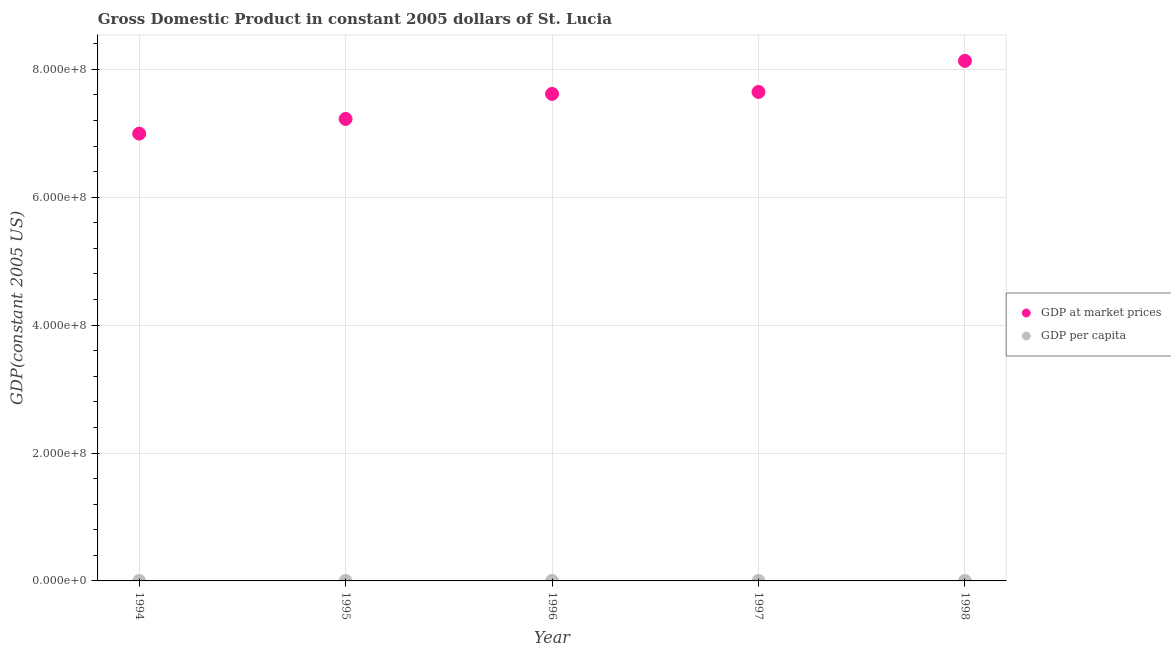What is the gdp per capita in 1997?
Offer a terse response. 5063.96. Across all years, what is the maximum gdp per capita?
Your answer should be very brief. 5312.77. Across all years, what is the minimum gdp at market prices?
Make the answer very short. 6.99e+08. In which year was the gdp per capita maximum?
Provide a succinct answer. 1998. In which year was the gdp per capita minimum?
Give a very brief answer. 1994. What is the total gdp per capita in the graph?
Keep it short and to the point. 2.52e+04. What is the difference between the gdp at market prices in 1995 and that in 1996?
Your answer should be very brief. -3.91e+07. What is the difference between the gdp per capita in 1996 and the gdp at market prices in 1995?
Your response must be concise. -7.22e+08. What is the average gdp at market prices per year?
Offer a very short reply. 7.52e+08. In the year 1997, what is the difference between the gdp at market prices and gdp per capita?
Your response must be concise. 7.65e+08. In how many years, is the gdp per capita greater than 80000000 US$?
Ensure brevity in your answer.  0. What is the ratio of the gdp per capita in 1995 to that in 1998?
Your answer should be very brief. 0.92. What is the difference between the highest and the second highest gdp per capita?
Your answer should be very brief. 200.38. What is the difference between the highest and the lowest gdp per capita?
Your answer should be very brief. 497.87. Does the gdp per capita monotonically increase over the years?
Provide a short and direct response. No. Is the gdp at market prices strictly greater than the gdp per capita over the years?
Provide a short and direct response. Yes. Is the gdp per capita strictly less than the gdp at market prices over the years?
Offer a terse response. Yes. How many years are there in the graph?
Your response must be concise. 5. Are the values on the major ticks of Y-axis written in scientific E-notation?
Ensure brevity in your answer.  Yes. Does the graph contain grids?
Your answer should be compact. Yes. Where does the legend appear in the graph?
Make the answer very short. Center right. How many legend labels are there?
Your answer should be compact. 2. What is the title of the graph?
Keep it short and to the point. Gross Domestic Product in constant 2005 dollars of St. Lucia. Does "Resident" appear as one of the legend labels in the graph?
Ensure brevity in your answer.  No. What is the label or title of the X-axis?
Offer a terse response. Year. What is the label or title of the Y-axis?
Your answer should be compact. GDP(constant 2005 US). What is the GDP(constant 2005 US) in GDP at market prices in 1994?
Ensure brevity in your answer.  6.99e+08. What is the GDP(constant 2005 US) of GDP per capita in 1994?
Provide a succinct answer. 4814.9. What is the GDP(constant 2005 US) in GDP at market prices in 1995?
Offer a very short reply. 7.22e+08. What is the GDP(constant 2005 US) in GDP per capita in 1995?
Offer a very short reply. 4913.07. What is the GDP(constant 2005 US) of GDP at market prices in 1996?
Your answer should be very brief. 7.62e+08. What is the GDP(constant 2005 US) in GDP per capita in 1996?
Provide a succinct answer. 5112.4. What is the GDP(constant 2005 US) in GDP at market prices in 1997?
Provide a succinct answer. 7.65e+08. What is the GDP(constant 2005 US) of GDP per capita in 1997?
Your response must be concise. 5063.96. What is the GDP(constant 2005 US) in GDP at market prices in 1998?
Offer a very short reply. 8.13e+08. What is the GDP(constant 2005 US) of GDP per capita in 1998?
Your answer should be compact. 5312.77. Across all years, what is the maximum GDP(constant 2005 US) in GDP at market prices?
Provide a short and direct response. 8.13e+08. Across all years, what is the maximum GDP(constant 2005 US) of GDP per capita?
Your answer should be very brief. 5312.77. Across all years, what is the minimum GDP(constant 2005 US) in GDP at market prices?
Your answer should be compact. 6.99e+08. Across all years, what is the minimum GDP(constant 2005 US) of GDP per capita?
Ensure brevity in your answer.  4814.9. What is the total GDP(constant 2005 US) in GDP at market prices in the graph?
Provide a succinct answer. 3.76e+09. What is the total GDP(constant 2005 US) of GDP per capita in the graph?
Ensure brevity in your answer.  2.52e+04. What is the difference between the GDP(constant 2005 US) in GDP at market prices in 1994 and that in 1995?
Your answer should be compact. -2.30e+07. What is the difference between the GDP(constant 2005 US) of GDP per capita in 1994 and that in 1995?
Ensure brevity in your answer.  -98.17. What is the difference between the GDP(constant 2005 US) of GDP at market prices in 1994 and that in 1996?
Your answer should be compact. -6.21e+07. What is the difference between the GDP(constant 2005 US) in GDP per capita in 1994 and that in 1996?
Your answer should be compact. -297.5. What is the difference between the GDP(constant 2005 US) of GDP at market prices in 1994 and that in 1997?
Offer a terse response. -6.52e+07. What is the difference between the GDP(constant 2005 US) of GDP per capita in 1994 and that in 1997?
Your response must be concise. -249.06. What is the difference between the GDP(constant 2005 US) in GDP at market prices in 1994 and that in 1998?
Offer a terse response. -1.14e+08. What is the difference between the GDP(constant 2005 US) in GDP per capita in 1994 and that in 1998?
Ensure brevity in your answer.  -497.87. What is the difference between the GDP(constant 2005 US) of GDP at market prices in 1995 and that in 1996?
Offer a very short reply. -3.91e+07. What is the difference between the GDP(constant 2005 US) in GDP per capita in 1995 and that in 1996?
Ensure brevity in your answer.  -199.33. What is the difference between the GDP(constant 2005 US) in GDP at market prices in 1995 and that in 1997?
Provide a short and direct response. -4.22e+07. What is the difference between the GDP(constant 2005 US) in GDP per capita in 1995 and that in 1997?
Provide a succinct answer. -150.89. What is the difference between the GDP(constant 2005 US) of GDP at market prices in 1995 and that in 1998?
Provide a short and direct response. -9.08e+07. What is the difference between the GDP(constant 2005 US) of GDP per capita in 1995 and that in 1998?
Provide a short and direct response. -399.7. What is the difference between the GDP(constant 2005 US) in GDP at market prices in 1996 and that in 1997?
Your answer should be compact. -3.07e+06. What is the difference between the GDP(constant 2005 US) in GDP per capita in 1996 and that in 1997?
Your answer should be compact. 48.44. What is the difference between the GDP(constant 2005 US) in GDP at market prices in 1996 and that in 1998?
Your response must be concise. -5.17e+07. What is the difference between the GDP(constant 2005 US) of GDP per capita in 1996 and that in 1998?
Your answer should be compact. -200.38. What is the difference between the GDP(constant 2005 US) of GDP at market prices in 1997 and that in 1998?
Your response must be concise. -4.86e+07. What is the difference between the GDP(constant 2005 US) of GDP per capita in 1997 and that in 1998?
Offer a very short reply. -248.82. What is the difference between the GDP(constant 2005 US) of GDP at market prices in 1994 and the GDP(constant 2005 US) of GDP per capita in 1995?
Make the answer very short. 6.99e+08. What is the difference between the GDP(constant 2005 US) of GDP at market prices in 1994 and the GDP(constant 2005 US) of GDP per capita in 1996?
Give a very brief answer. 6.99e+08. What is the difference between the GDP(constant 2005 US) in GDP at market prices in 1994 and the GDP(constant 2005 US) in GDP per capita in 1997?
Offer a very short reply. 6.99e+08. What is the difference between the GDP(constant 2005 US) of GDP at market prices in 1994 and the GDP(constant 2005 US) of GDP per capita in 1998?
Your answer should be very brief. 6.99e+08. What is the difference between the GDP(constant 2005 US) in GDP at market prices in 1995 and the GDP(constant 2005 US) in GDP per capita in 1996?
Your answer should be compact. 7.22e+08. What is the difference between the GDP(constant 2005 US) of GDP at market prices in 1995 and the GDP(constant 2005 US) of GDP per capita in 1997?
Keep it short and to the point. 7.22e+08. What is the difference between the GDP(constant 2005 US) of GDP at market prices in 1995 and the GDP(constant 2005 US) of GDP per capita in 1998?
Offer a terse response. 7.22e+08. What is the difference between the GDP(constant 2005 US) in GDP at market prices in 1996 and the GDP(constant 2005 US) in GDP per capita in 1997?
Your answer should be compact. 7.62e+08. What is the difference between the GDP(constant 2005 US) of GDP at market prices in 1996 and the GDP(constant 2005 US) of GDP per capita in 1998?
Your answer should be compact. 7.62e+08. What is the difference between the GDP(constant 2005 US) in GDP at market prices in 1997 and the GDP(constant 2005 US) in GDP per capita in 1998?
Your answer should be compact. 7.65e+08. What is the average GDP(constant 2005 US) of GDP at market prices per year?
Make the answer very short. 7.52e+08. What is the average GDP(constant 2005 US) in GDP per capita per year?
Provide a succinct answer. 5043.42. In the year 1994, what is the difference between the GDP(constant 2005 US) of GDP at market prices and GDP(constant 2005 US) of GDP per capita?
Offer a terse response. 6.99e+08. In the year 1995, what is the difference between the GDP(constant 2005 US) in GDP at market prices and GDP(constant 2005 US) in GDP per capita?
Your answer should be very brief. 7.22e+08. In the year 1996, what is the difference between the GDP(constant 2005 US) of GDP at market prices and GDP(constant 2005 US) of GDP per capita?
Ensure brevity in your answer.  7.62e+08. In the year 1997, what is the difference between the GDP(constant 2005 US) in GDP at market prices and GDP(constant 2005 US) in GDP per capita?
Provide a succinct answer. 7.65e+08. In the year 1998, what is the difference between the GDP(constant 2005 US) of GDP at market prices and GDP(constant 2005 US) of GDP per capita?
Your answer should be very brief. 8.13e+08. What is the ratio of the GDP(constant 2005 US) of GDP at market prices in 1994 to that in 1995?
Your answer should be compact. 0.97. What is the ratio of the GDP(constant 2005 US) of GDP at market prices in 1994 to that in 1996?
Offer a very short reply. 0.92. What is the ratio of the GDP(constant 2005 US) in GDP per capita in 1994 to that in 1996?
Offer a terse response. 0.94. What is the ratio of the GDP(constant 2005 US) of GDP at market prices in 1994 to that in 1997?
Give a very brief answer. 0.91. What is the ratio of the GDP(constant 2005 US) of GDP per capita in 1994 to that in 1997?
Provide a succinct answer. 0.95. What is the ratio of the GDP(constant 2005 US) in GDP at market prices in 1994 to that in 1998?
Offer a very short reply. 0.86. What is the ratio of the GDP(constant 2005 US) in GDP per capita in 1994 to that in 1998?
Ensure brevity in your answer.  0.91. What is the ratio of the GDP(constant 2005 US) in GDP at market prices in 1995 to that in 1996?
Your answer should be compact. 0.95. What is the ratio of the GDP(constant 2005 US) in GDP per capita in 1995 to that in 1996?
Keep it short and to the point. 0.96. What is the ratio of the GDP(constant 2005 US) of GDP at market prices in 1995 to that in 1997?
Give a very brief answer. 0.94. What is the ratio of the GDP(constant 2005 US) in GDP per capita in 1995 to that in 1997?
Provide a short and direct response. 0.97. What is the ratio of the GDP(constant 2005 US) of GDP at market prices in 1995 to that in 1998?
Provide a succinct answer. 0.89. What is the ratio of the GDP(constant 2005 US) in GDP per capita in 1995 to that in 1998?
Your answer should be very brief. 0.92. What is the ratio of the GDP(constant 2005 US) of GDP at market prices in 1996 to that in 1997?
Make the answer very short. 1. What is the ratio of the GDP(constant 2005 US) of GDP per capita in 1996 to that in 1997?
Provide a short and direct response. 1.01. What is the ratio of the GDP(constant 2005 US) in GDP at market prices in 1996 to that in 1998?
Keep it short and to the point. 0.94. What is the ratio of the GDP(constant 2005 US) of GDP per capita in 1996 to that in 1998?
Give a very brief answer. 0.96. What is the ratio of the GDP(constant 2005 US) in GDP at market prices in 1997 to that in 1998?
Your answer should be very brief. 0.94. What is the ratio of the GDP(constant 2005 US) in GDP per capita in 1997 to that in 1998?
Your response must be concise. 0.95. What is the difference between the highest and the second highest GDP(constant 2005 US) of GDP at market prices?
Make the answer very short. 4.86e+07. What is the difference between the highest and the second highest GDP(constant 2005 US) in GDP per capita?
Offer a very short reply. 200.38. What is the difference between the highest and the lowest GDP(constant 2005 US) of GDP at market prices?
Your answer should be compact. 1.14e+08. What is the difference between the highest and the lowest GDP(constant 2005 US) of GDP per capita?
Give a very brief answer. 497.87. 